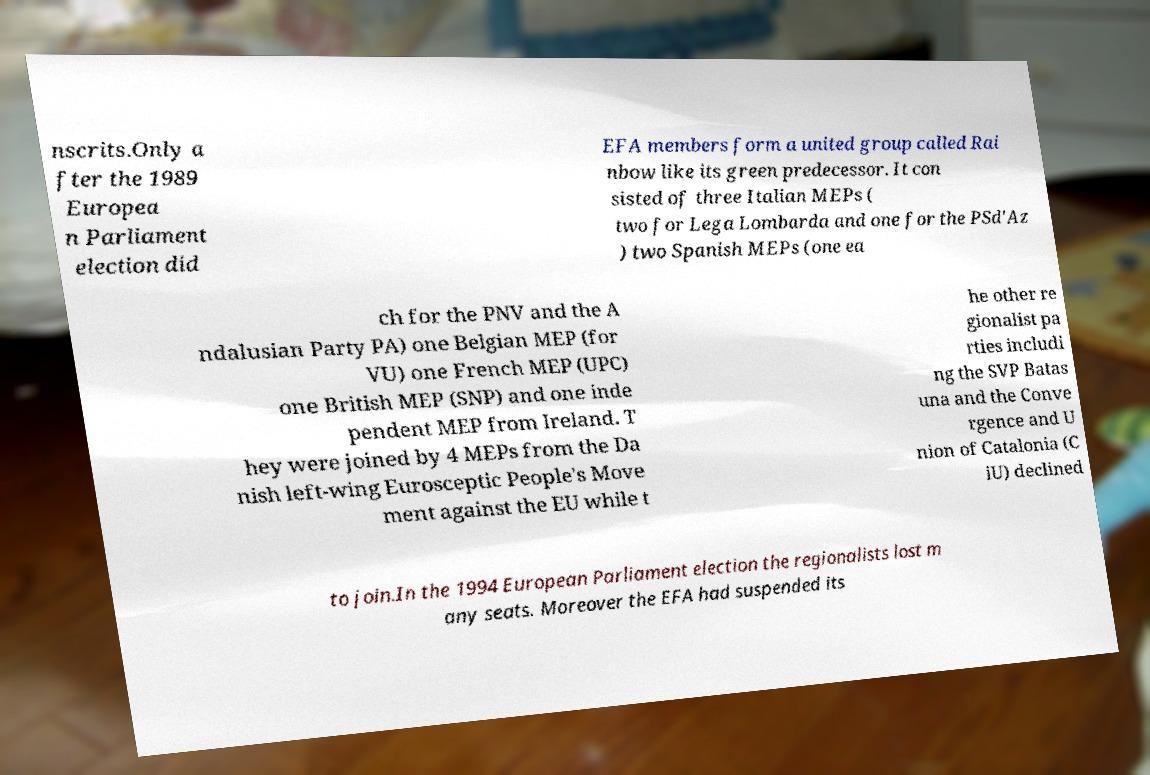Please identify and transcribe the text found in this image. nscrits.Only a fter the 1989 Europea n Parliament election did EFA members form a united group called Rai nbow like its green predecessor. It con sisted of three Italian MEPs ( two for Lega Lombarda and one for the PSd'Az ) two Spanish MEPs (one ea ch for the PNV and the A ndalusian Party PA) one Belgian MEP (for VU) one French MEP (UPC) one British MEP (SNP) and one inde pendent MEP from Ireland. T hey were joined by 4 MEPs from the Da nish left-wing Eurosceptic People's Move ment against the EU while t he other re gionalist pa rties includi ng the SVP Batas una and the Conve rgence and U nion of Catalonia (C iU) declined to join.In the 1994 European Parliament election the regionalists lost m any seats. Moreover the EFA had suspended its 